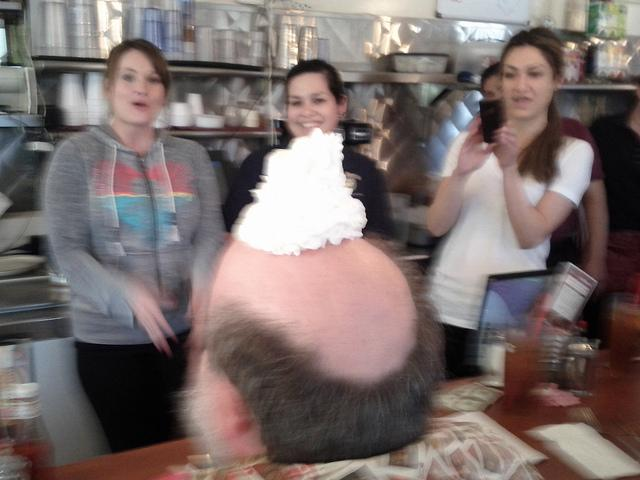What does the woman do with her phone? Please explain your reasoning. take photo. The woman is taking a picture of the man with shaving cream on his head. 